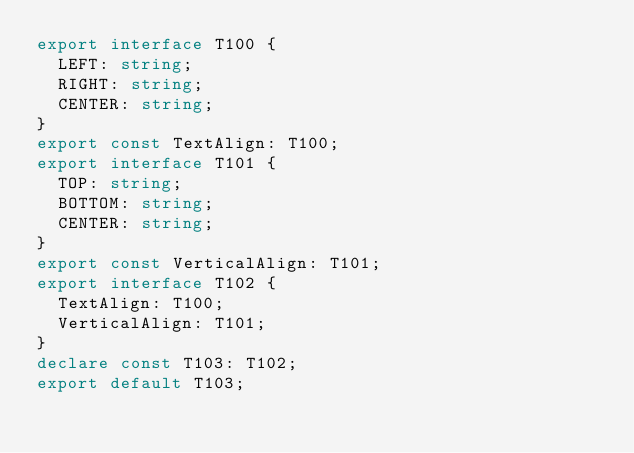Convert code to text. <code><loc_0><loc_0><loc_500><loc_500><_TypeScript_>export interface T100 {
  LEFT: string;
  RIGHT: string;
  CENTER: string;
}
export const TextAlign: T100;
export interface T101 {
  TOP: string;
  BOTTOM: string;
  CENTER: string;
}
export const VerticalAlign: T101;
export interface T102 {
  TextAlign: T100;
  VerticalAlign: T101;
}
declare const T103: T102;
export default T103;
</code> 